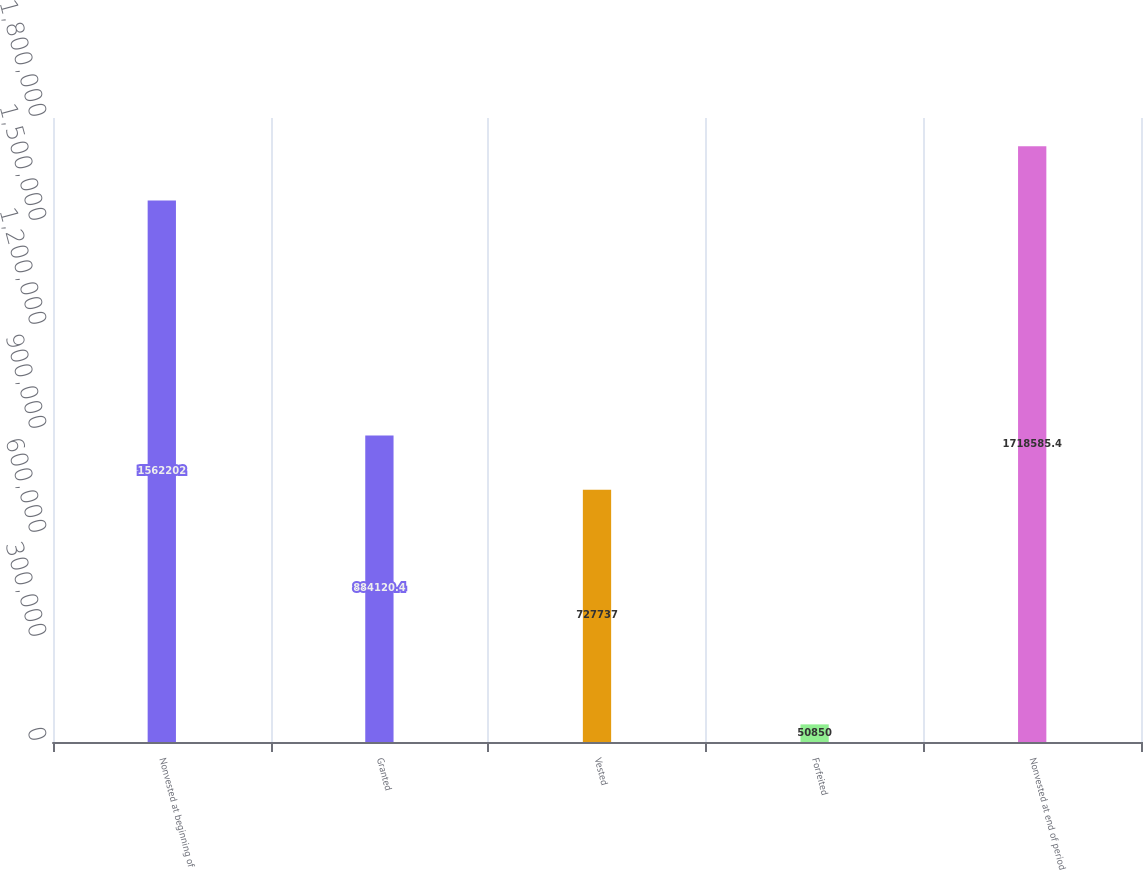Convert chart to OTSL. <chart><loc_0><loc_0><loc_500><loc_500><bar_chart><fcel>Nonvested at beginning of<fcel>Granted<fcel>Vested<fcel>Forfeited<fcel>Nonvested at end of period<nl><fcel>1.5622e+06<fcel>884120<fcel>727737<fcel>50850<fcel>1.71859e+06<nl></chart> 